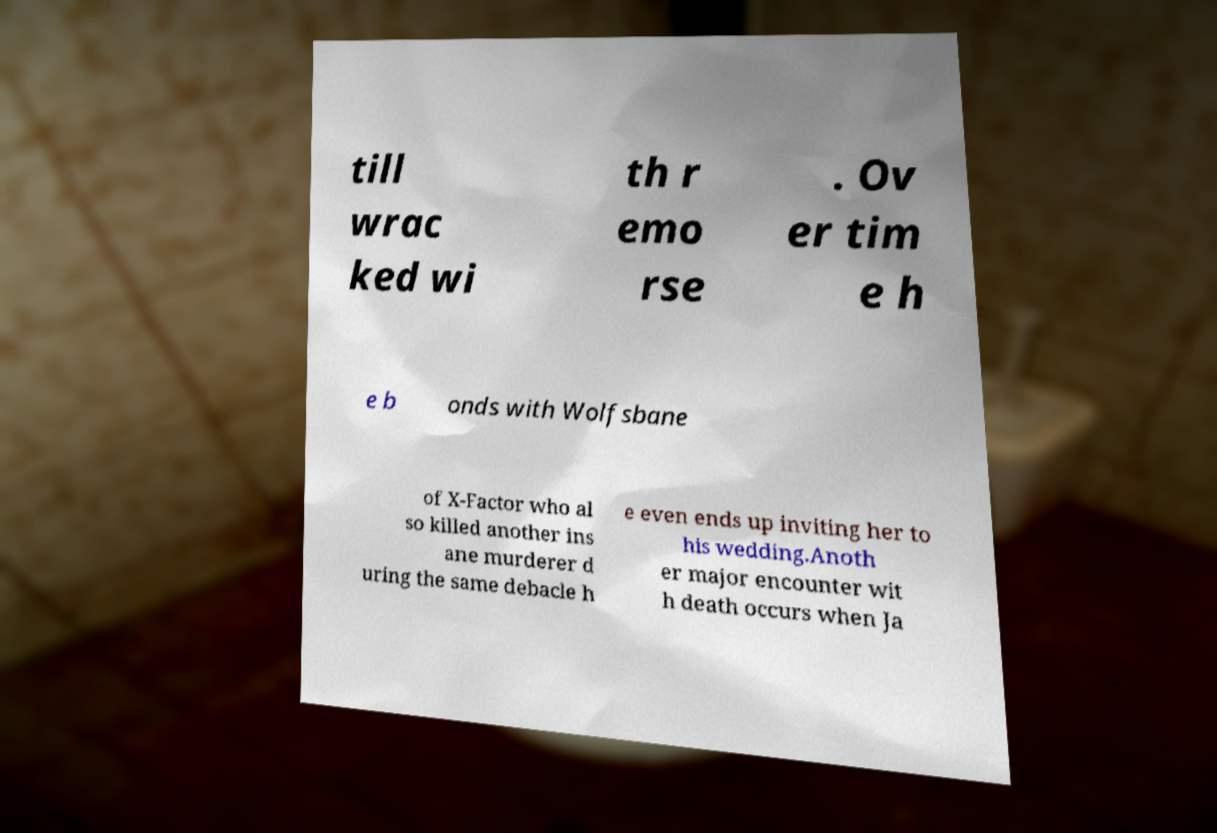Could you extract and type out the text from this image? till wrac ked wi th r emo rse . Ov er tim e h e b onds with Wolfsbane of X-Factor who al so killed another ins ane murderer d uring the same debacle h e even ends up inviting her to his wedding.Anoth er major encounter wit h death occurs when Ja 